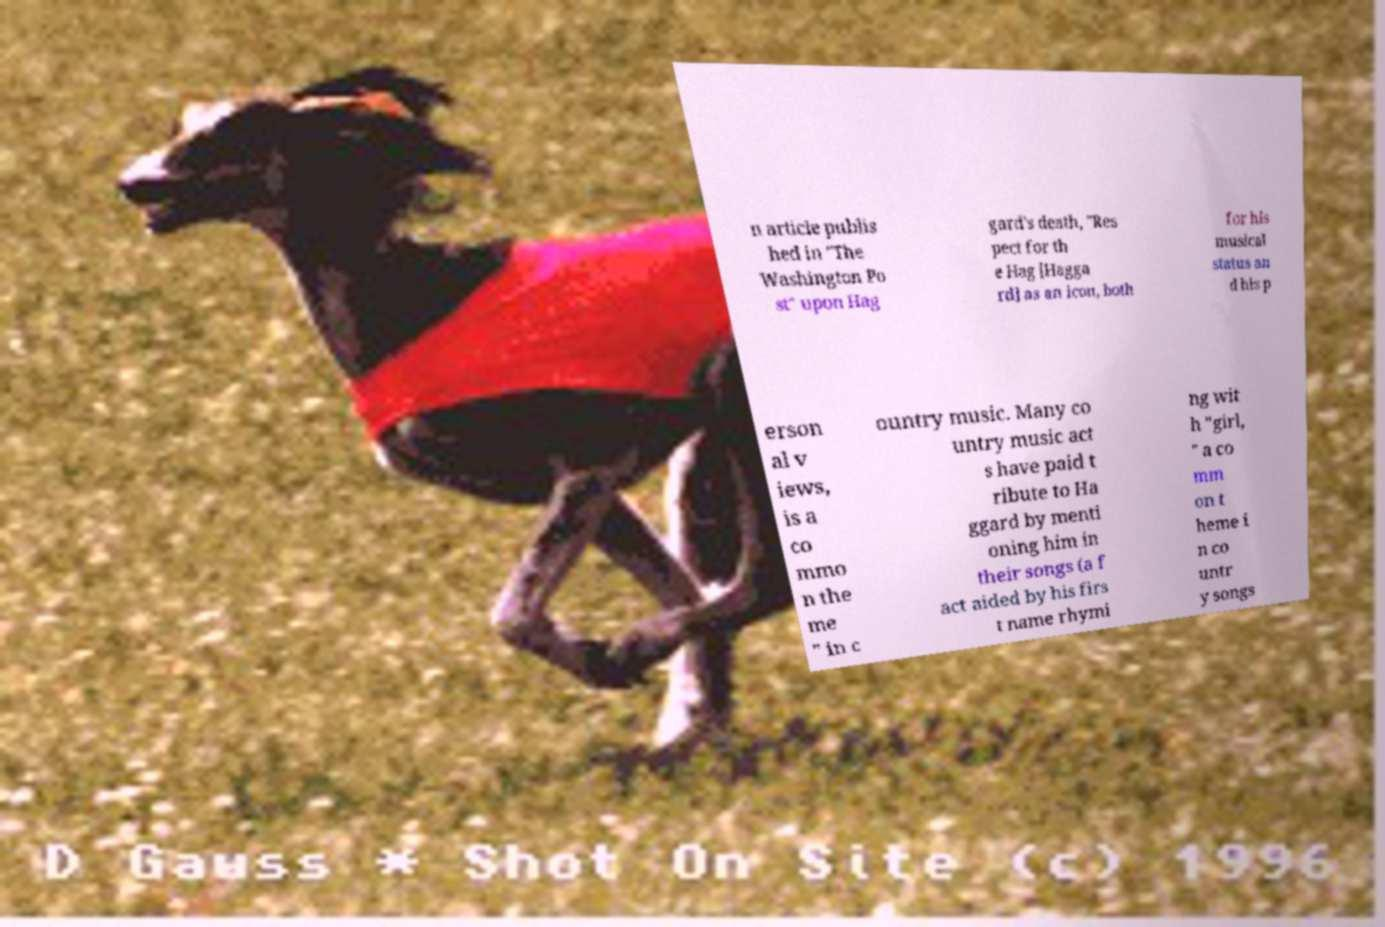Can you accurately transcribe the text from the provided image for me? n article publis hed in "The Washington Po st" upon Hag gard's death, "Res pect for th e Hag [Hagga rd] as an icon, both for his musical status an d his p erson al v iews, is a co mmo n the me " in c ountry music. Many co untry music act s have paid t ribute to Ha ggard by menti oning him in their songs (a f act aided by his firs t name rhymi ng wit h "girl, " a co mm on t heme i n co untr y songs 